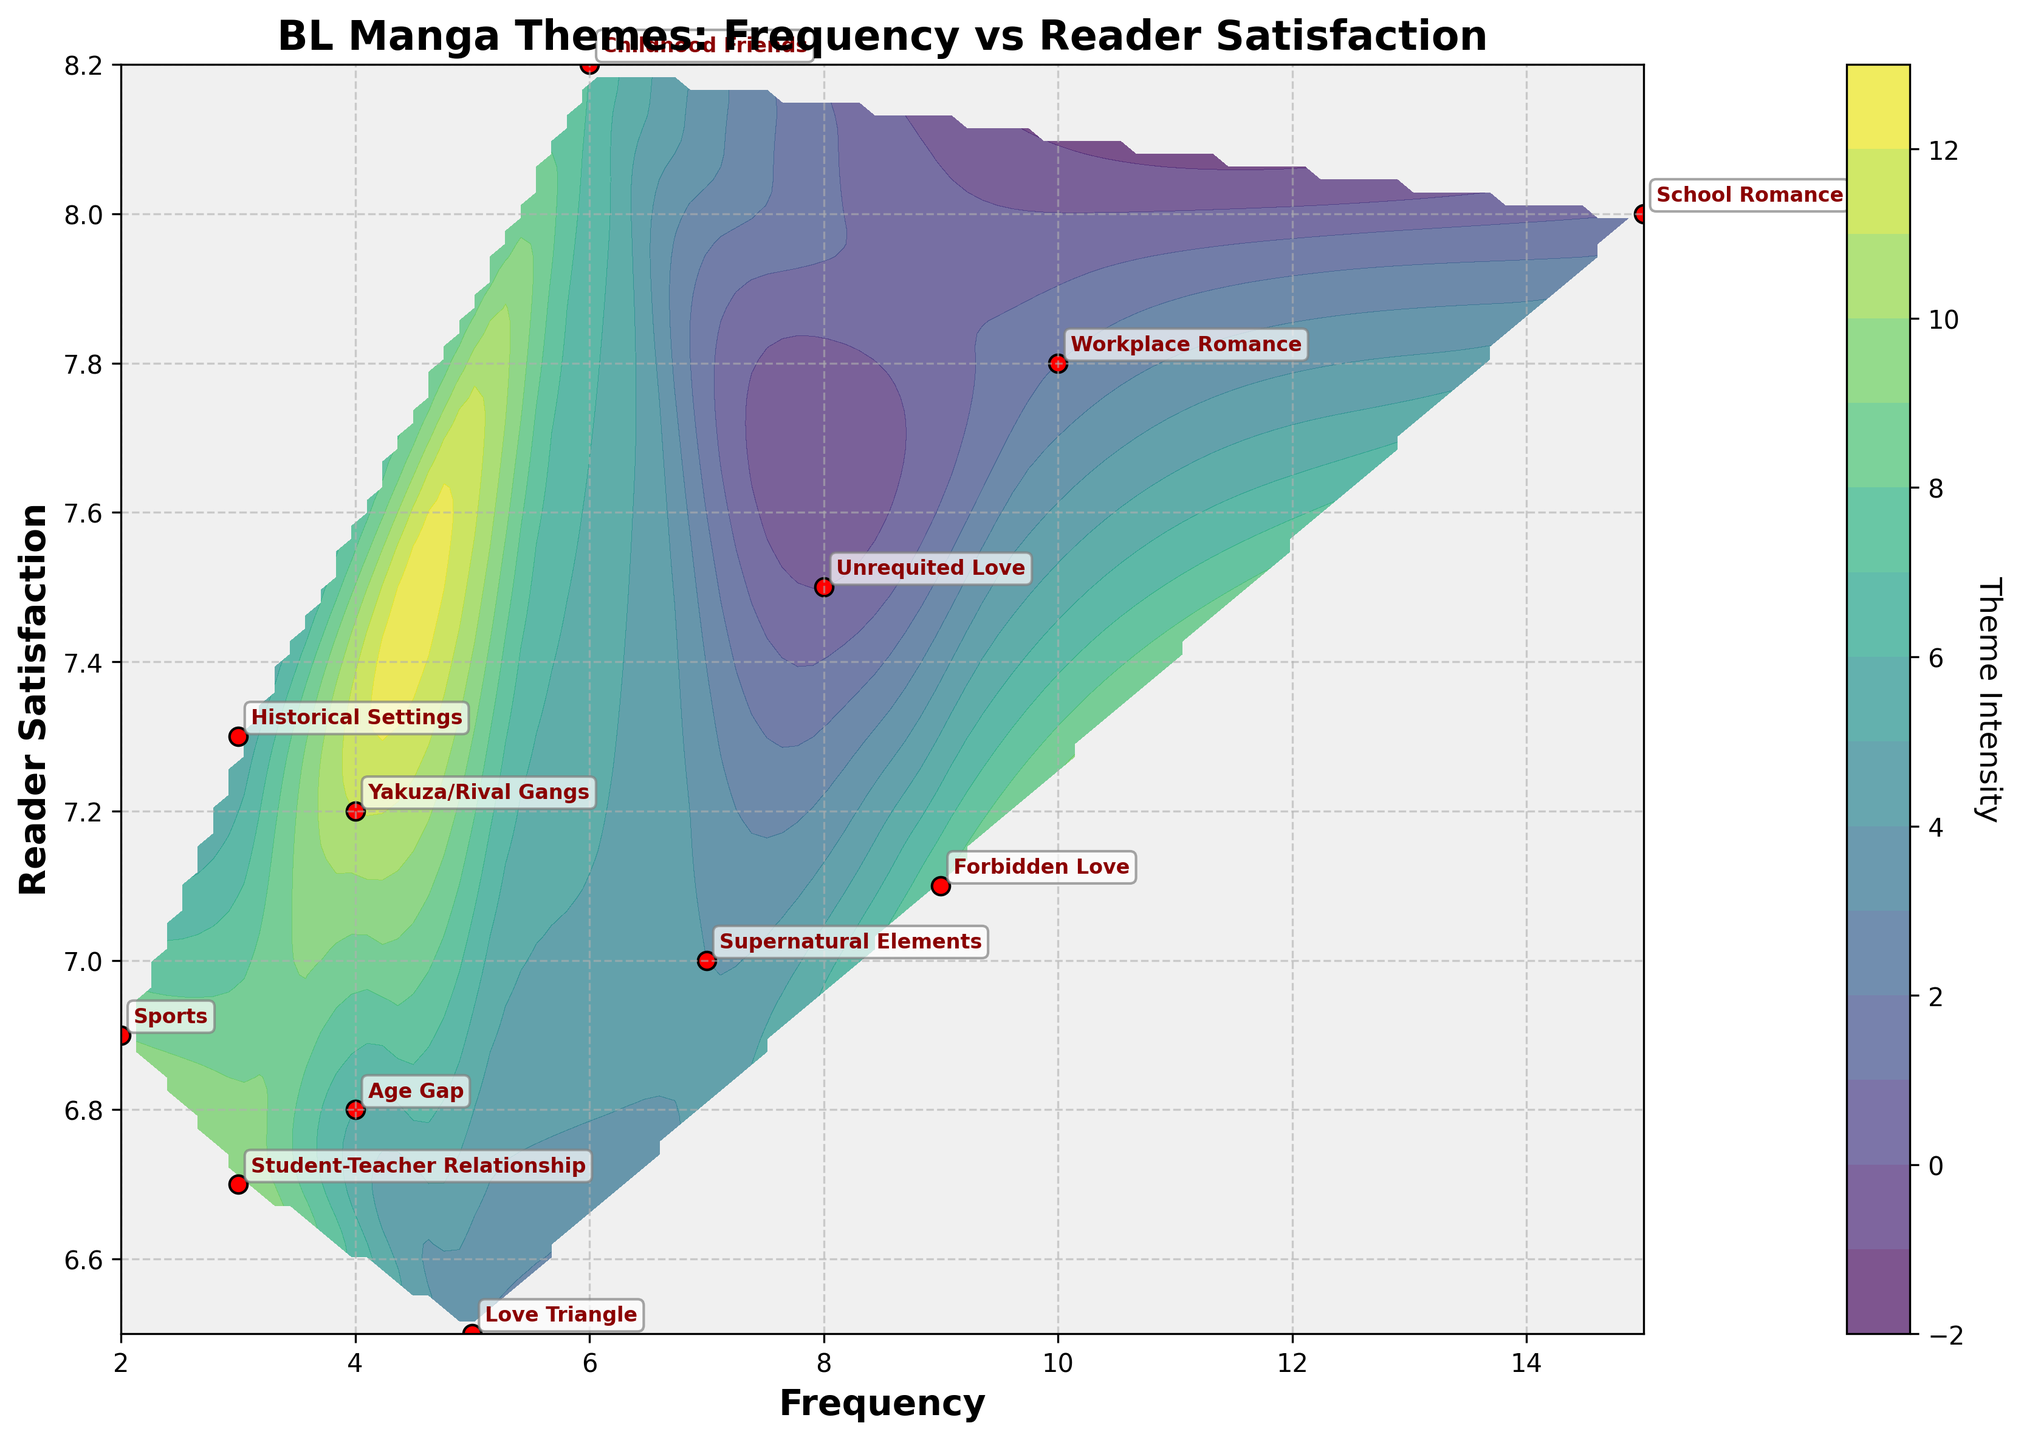What is the title of the plot? The title is located at the top of the plot and is usually written in a larger and bolder font. Observing the top of the figure, the title reads "BL Manga Themes: Frequency vs Reader Satisfaction".
Answer: BL Manga Themes: Frequency vs Reader Satisfaction How many different themes are plotted on the figure? Each theme is represented by a red dot on the plot. Counting all the red dots, there are 12 distinct themes.
Answer: 12 Which theme has the highest frequency and what is its corresponding reader satisfaction level? Locate the theme with the highest frequency on the x-axis. The "School Romance" theme is furthest to the right, with a frequency of 15 and a reader satisfaction level of 8.0.
Answer: School Romance, 8.0 Compare the reader satisfaction levels of "Unrequited Love" and "Forbidden Love". Which one is higher? Find both themes on the plot and compare their positions on the y-axis. "Unrequited Love" has a satisfaction level of 7.5, whereas "Forbidden Love" has a level of 7.1. "Unrequited Love" is higher.
Answer: Unrequited Love What is the average frequency of themes with a reader satisfaction level above 7.0? Identify the themes with reader satisfaction levels above 7.0: "Unrequited Love", "School Romance", "Workplace Romance", "Supernatural Elements", "Historical Settings", "Childhood Friends", and "Forbidden Love". Their frequencies are 8, 15, 10, 7, 3, 6, and 9 respectively. Calculate the average: (8 + 15 + 10 + 7 + 3 + 6 + 9) / 7 = 8.3.
Answer: 8.3 Which theme shows the lowest frequency and what is its reader satisfaction level? Locate the theme with the lowest frequency on the x-axis. "Sports" has the lowest frequency (2), with a reader satisfaction level of 6.9.
Answer: Sports, 6.9 Is there a general trend between theme frequency and reader satisfaction? By observing the scatter and contour plot, it seems that themes with higher frequencies generally have higher reader satisfaction, though there are exceptions.
Answer: Generally positive Which themes have a reader satisfaction between 6.5 and 7.0? Identify the themes that fall between these values on the y-axis: "Love Triangle" (6.5), "Age Gap" (6.8), "Sports" (6.9), and "Student-Teacher Relationship" (6.7).
Answer: Love Triangle, Age Gap, Sports, Student-Teacher Relationship 